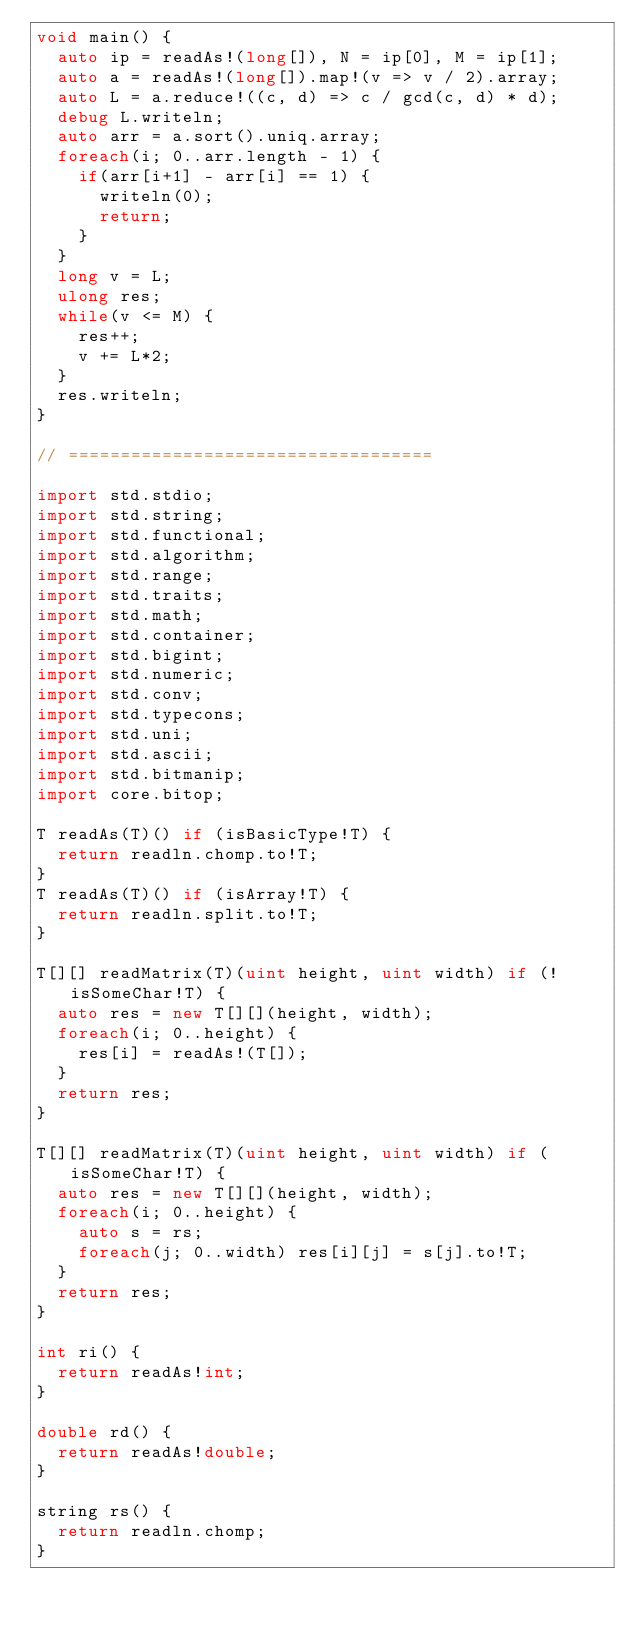<code> <loc_0><loc_0><loc_500><loc_500><_D_>void main() {
	auto ip = readAs!(long[]), N = ip[0], M = ip[1];
	auto a = readAs!(long[]).map!(v => v / 2).array;
	auto L = a.reduce!((c, d) => c / gcd(c, d) * d);
	debug L.writeln;
	auto arr = a.sort().uniq.array;
	foreach(i; 0..arr.length - 1) {
		if(arr[i+1] - arr[i] == 1) {
			writeln(0);
			return;
		}
	}
	long v = L;
	ulong res;
	while(v <= M) {
		res++;
		v += L*2;
	}
	res.writeln;
}

// ===================================

import std.stdio;
import std.string;
import std.functional;
import std.algorithm;
import std.range;
import std.traits;
import std.math;
import std.container;
import std.bigint;
import std.numeric;
import std.conv;
import std.typecons;
import std.uni;
import std.ascii;
import std.bitmanip;
import core.bitop;

T readAs(T)() if (isBasicType!T) {
	return readln.chomp.to!T;
}
T readAs(T)() if (isArray!T) {
	return readln.split.to!T;
}

T[][] readMatrix(T)(uint height, uint width) if (!isSomeChar!T) {
	auto res = new T[][](height, width);
	foreach(i; 0..height) {
		res[i] = readAs!(T[]);
	}
	return res;
}

T[][] readMatrix(T)(uint height, uint width) if (isSomeChar!T) {
	auto res = new T[][](height, width);
	foreach(i; 0..height) {
		auto s = rs;
		foreach(j; 0..width) res[i][j] = s[j].to!T;
	}
	return res;
}

int ri() {
	return readAs!int;
}

double rd() {
	return readAs!double;
}

string rs() {
	return readln.chomp;
}</code> 